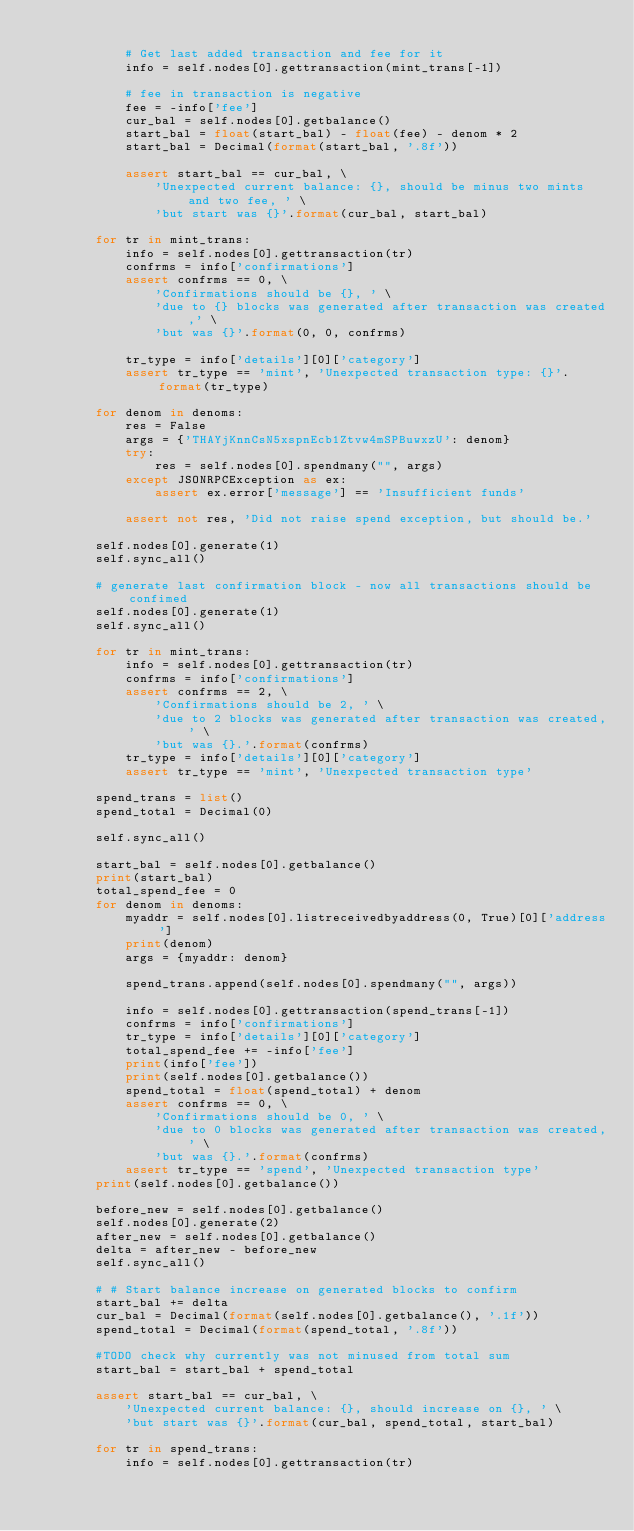<code> <loc_0><loc_0><loc_500><loc_500><_Python_>
            # Get last added transaction and fee for it
            info = self.nodes[0].gettransaction(mint_trans[-1])

            # fee in transaction is negative
            fee = -info['fee']
            cur_bal = self.nodes[0].getbalance()
            start_bal = float(start_bal) - float(fee) - denom * 2
            start_bal = Decimal(format(start_bal, '.8f'))

            assert start_bal == cur_bal, \
                'Unexpected current balance: {}, should be minus two mints and two fee, ' \
                'but start was {}'.format(cur_bal, start_bal)

        for tr in mint_trans:
            info = self.nodes[0].gettransaction(tr)
            confrms = info['confirmations']
            assert confrms == 0, \
                'Confirmations should be {}, ' \
                'due to {} blocks was generated after transaction was created,' \
                'but was {}'.format(0, 0, confrms)

            tr_type = info['details'][0]['category']
            assert tr_type == 'mint', 'Unexpected transaction type: {}'.format(tr_type)

        for denom in denoms:
            res = False
            args = {'THAYjKnnCsN5xspnEcb1Ztvw4mSPBuwxzU': denom}
            try:
                res = self.nodes[0].spendmany("", args)
            except JSONRPCException as ex:
                assert ex.error['message'] == 'Insufficient funds'

            assert not res, 'Did not raise spend exception, but should be.'

        self.nodes[0].generate(1)
        self.sync_all()

        # generate last confirmation block - now all transactions should be confimed
        self.nodes[0].generate(1)
        self.sync_all()

        for tr in mint_trans:
            info = self.nodes[0].gettransaction(tr)
            confrms = info['confirmations']
            assert confrms == 2, \
                'Confirmations should be 2, ' \
                'due to 2 blocks was generated after transaction was created,' \
                'but was {}.'.format(confrms)
            tr_type = info['details'][0]['category']
            assert tr_type == 'mint', 'Unexpected transaction type'

        spend_trans = list()
        spend_total = Decimal(0)

        self.sync_all()

        start_bal = self.nodes[0].getbalance()
        print(start_bal)
        total_spend_fee = 0
        for denom in denoms:
            myaddr = self.nodes[0].listreceivedbyaddress(0, True)[0]['address']
            print(denom)
            args = {myaddr: denom}

            spend_trans.append(self.nodes[0].spendmany("", args))

            info = self.nodes[0].gettransaction(spend_trans[-1])
            confrms = info['confirmations']
            tr_type = info['details'][0]['category']
            total_spend_fee += -info['fee']
            print(info['fee'])
            print(self.nodes[0].getbalance())
            spend_total = float(spend_total) + denom
            assert confrms == 0, \
                'Confirmations should be 0, ' \
                'due to 0 blocks was generated after transaction was created,' \
                'but was {}.'.format(confrms)
            assert tr_type == 'spend', 'Unexpected transaction type'
        print(self.nodes[0].getbalance())

        before_new = self.nodes[0].getbalance()
        self.nodes[0].generate(2)
        after_new = self.nodes[0].getbalance()
        delta = after_new - before_new
        self.sync_all()

        # # Start balance increase on generated blocks to confirm
        start_bal += delta
        cur_bal = Decimal(format(self.nodes[0].getbalance(), '.1f'))
        spend_total = Decimal(format(spend_total, '.8f'))

        #TODO check why currently was not minused from total sum
        start_bal = start_bal + spend_total

        assert start_bal == cur_bal, \
            'Unexpected current balance: {}, should increase on {}, ' \
            'but start was {}'.format(cur_bal, spend_total, start_bal)

        for tr in spend_trans:
            info = self.nodes[0].gettransaction(tr)
</code> 